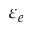<formula> <loc_0><loc_0><loc_500><loc_500>\varepsilon _ { e }</formula> 